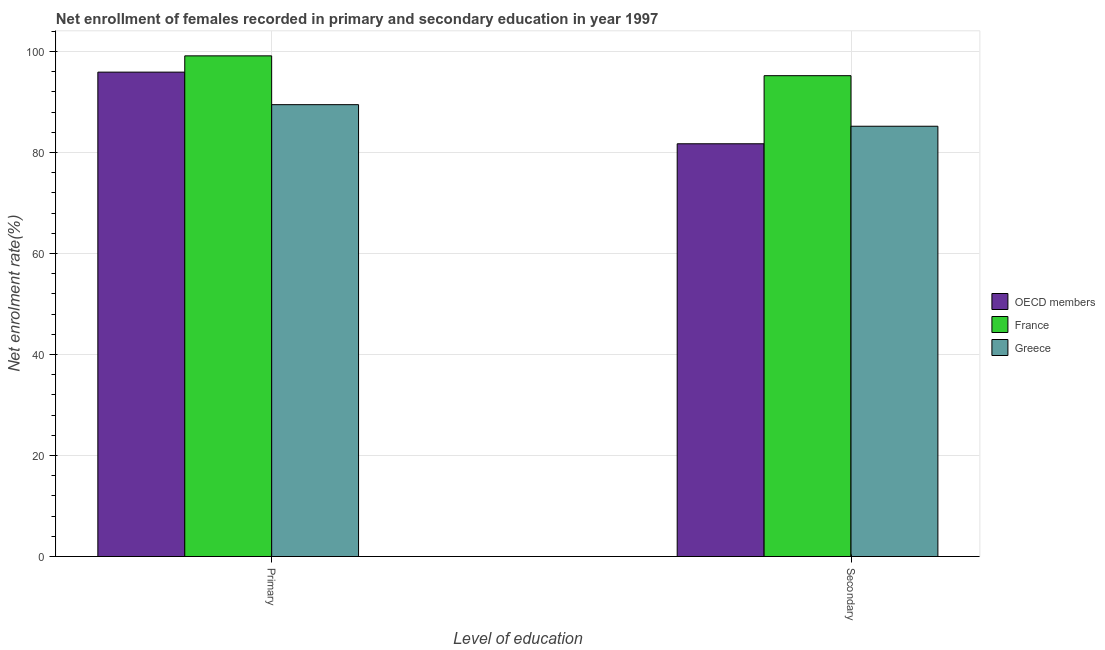Are the number of bars per tick equal to the number of legend labels?
Ensure brevity in your answer.  Yes. Are the number of bars on each tick of the X-axis equal?
Your answer should be very brief. Yes. How many bars are there on the 2nd tick from the left?
Your answer should be very brief. 3. How many bars are there on the 2nd tick from the right?
Give a very brief answer. 3. What is the label of the 1st group of bars from the left?
Your answer should be compact. Primary. What is the enrollment rate in primary education in OECD members?
Provide a succinct answer. 95.93. Across all countries, what is the maximum enrollment rate in secondary education?
Offer a very short reply. 95.23. Across all countries, what is the minimum enrollment rate in primary education?
Provide a short and direct response. 89.49. In which country was the enrollment rate in secondary education maximum?
Make the answer very short. France. In which country was the enrollment rate in secondary education minimum?
Offer a very short reply. OECD members. What is the total enrollment rate in primary education in the graph?
Give a very brief answer. 284.58. What is the difference between the enrollment rate in secondary education in Greece and that in OECD members?
Provide a succinct answer. 3.47. What is the difference between the enrollment rate in secondary education in France and the enrollment rate in primary education in OECD members?
Provide a short and direct response. -0.7. What is the average enrollment rate in primary education per country?
Provide a short and direct response. 94.86. What is the difference between the enrollment rate in primary education and enrollment rate in secondary education in Greece?
Provide a succinct answer. 4.27. What is the ratio of the enrollment rate in secondary education in OECD members to that in Greece?
Ensure brevity in your answer.  0.96. In how many countries, is the enrollment rate in primary education greater than the average enrollment rate in primary education taken over all countries?
Provide a short and direct response. 2. What does the 3rd bar from the right in Secondary represents?
Keep it short and to the point. OECD members. Are all the bars in the graph horizontal?
Give a very brief answer. No. How many countries are there in the graph?
Your answer should be very brief. 3. What is the difference between two consecutive major ticks on the Y-axis?
Offer a terse response. 20. Are the values on the major ticks of Y-axis written in scientific E-notation?
Give a very brief answer. No. Does the graph contain grids?
Keep it short and to the point. Yes. How are the legend labels stacked?
Provide a short and direct response. Vertical. What is the title of the graph?
Provide a short and direct response. Net enrollment of females recorded in primary and secondary education in year 1997. What is the label or title of the X-axis?
Ensure brevity in your answer.  Level of education. What is the label or title of the Y-axis?
Keep it short and to the point. Net enrolment rate(%). What is the Net enrolment rate(%) in OECD members in Primary?
Your answer should be compact. 95.93. What is the Net enrolment rate(%) of France in Primary?
Your response must be concise. 99.16. What is the Net enrolment rate(%) in Greece in Primary?
Your answer should be compact. 89.49. What is the Net enrolment rate(%) in OECD members in Secondary?
Offer a very short reply. 81.75. What is the Net enrolment rate(%) in France in Secondary?
Your answer should be very brief. 95.23. What is the Net enrolment rate(%) of Greece in Secondary?
Make the answer very short. 85.22. Across all Level of education, what is the maximum Net enrolment rate(%) in OECD members?
Make the answer very short. 95.93. Across all Level of education, what is the maximum Net enrolment rate(%) in France?
Your answer should be very brief. 99.16. Across all Level of education, what is the maximum Net enrolment rate(%) in Greece?
Offer a very short reply. 89.49. Across all Level of education, what is the minimum Net enrolment rate(%) of OECD members?
Provide a short and direct response. 81.75. Across all Level of education, what is the minimum Net enrolment rate(%) of France?
Ensure brevity in your answer.  95.23. Across all Level of education, what is the minimum Net enrolment rate(%) of Greece?
Offer a terse response. 85.22. What is the total Net enrolment rate(%) in OECD members in the graph?
Provide a short and direct response. 177.68. What is the total Net enrolment rate(%) of France in the graph?
Keep it short and to the point. 194.38. What is the total Net enrolment rate(%) in Greece in the graph?
Offer a very short reply. 174.71. What is the difference between the Net enrolment rate(%) in OECD members in Primary and that in Secondary?
Your response must be concise. 14.19. What is the difference between the Net enrolment rate(%) of France in Primary and that in Secondary?
Offer a very short reply. 3.93. What is the difference between the Net enrolment rate(%) of Greece in Primary and that in Secondary?
Ensure brevity in your answer.  4.27. What is the difference between the Net enrolment rate(%) of OECD members in Primary and the Net enrolment rate(%) of France in Secondary?
Your response must be concise. 0.7. What is the difference between the Net enrolment rate(%) of OECD members in Primary and the Net enrolment rate(%) of Greece in Secondary?
Provide a short and direct response. 10.72. What is the difference between the Net enrolment rate(%) in France in Primary and the Net enrolment rate(%) in Greece in Secondary?
Offer a very short reply. 13.94. What is the average Net enrolment rate(%) of OECD members per Level of education?
Your response must be concise. 88.84. What is the average Net enrolment rate(%) of France per Level of education?
Your answer should be very brief. 97.19. What is the average Net enrolment rate(%) of Greece per Level of education?
Offer a very short reply. 87.35. What is the difference between the Net enrolment rate(%) of OECD members and Net enrolment rate(%) of France in Primary?
Make the answer very short. -3.22. What is the difference between the Net enrolment rate(%) of OECD members and Net enrolment rate(%) of Greece in Primary?
Offer a terse response. 6.44. What is the difference between the Net enrolment rate(%) in France and Net enrolment rate(%) in Greece in Primary?
Your answer should be very brief. 9.67. What is the difference between the Net enrolment rate(%) of OECD members and Net enrolment rate(%) of France in Secondary?
Give a very brief answer. -13.48. What is the difference between the Net enrolment rate(%) of OECD members and Net enrolment rate(%) of Greece in Secondary?
Provide a succinct answer. -3.47. What is the difference between the Net enrolment rate(%) in France and Net enrolment rate(%) in Greece in Secondary?
Give a very brief answer. 10.01. What is the ratio of the Net enrolment rate(%) in OECD members in Primary to that in Secondary?
Offer a terse response. 1.17. What is the ratio of the Net enrolment rate(%) of France in Primary to that in Secondary?
Give a very brief answer. 1.04. What is the ratio of the Net enrolment rate(%) of Greece in Primary to that in Secondary?
Provide a succinct answer. 1.05. What is the difference between the highest and the second highest Net enrolment rate(%) in OECD members?
Provide a short and direct response. 14.19. What is the difference between the highest and the second highest Net enrolment rate(%) in France?
Give a very brief answer. 3.93. What is the difference between the highest and the second highest Net enrolment rate(%) of Greece?
Offer a very short reply. 4.27. What is the difference between the highest and the lowest Net enrolment rate(%) of OECD members?
Make the answer very short. 14.19. What is the difference between the highest and the lowest Net enrolment rate(%) in France?
Keep it short and to the point. 3.93. What is the difference between the highest and the lowest Net enrolment rate(%) in Greece?
Your response must be concise. 4.27. 